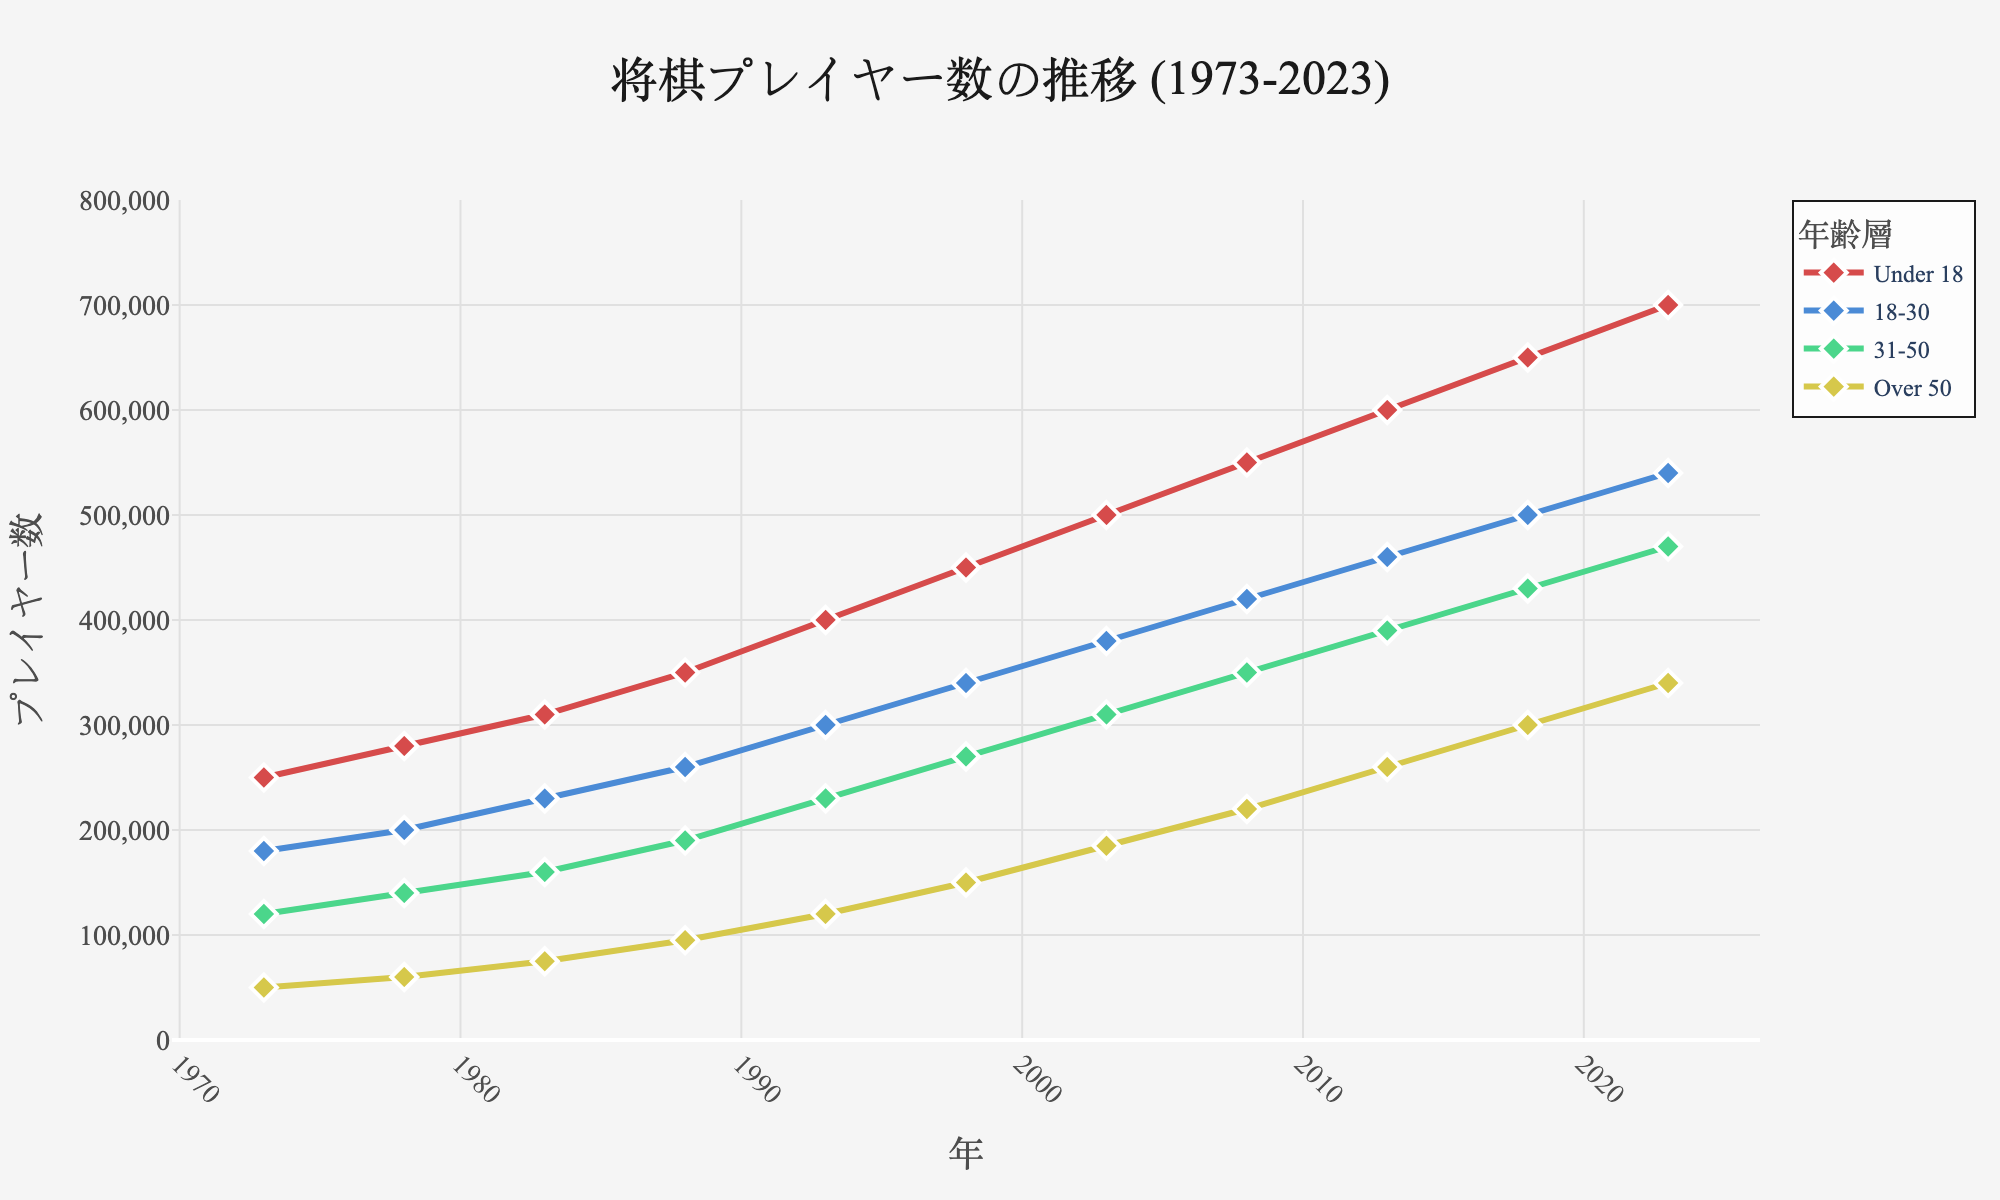What is the trend of shogi players in the "Under 18" age group over the past 50 years? The "Under 18" age group shows a steadily increasing trend in the number of shogi players from 250,000 in 1973 to 700,000 in 2023. This indicates a growing interest among the younger population over time.
Answer: Increasing Compare the number of shogi players in the "18-30" age group with the "31-50" age group in 2023. Which group has more players? In 2023, the number of shogi players in the "18-30" age group is 540,000, while in the "31-50" age group, it is 470,000. By comparing these numbers, the "18-30" age group has more players than the "31-50" age group.
Answer: "18-30" age group Among which age group(s) do you see a marked increase in the number of players post-2003? Post-2003, both the "Under 18" and "Over 50" age groups see a marked increase. The "Under 18" group rises from 500,000 (2003) to 700,000 (2023) and the "Over 50" group moves from 185,000 (2003) to 340,000 (2023), showing a growing trend in these age groups.
Answer: "Under 18" and "Over 50" age groups What is the visual color used for the "31-50" age group line in the graph? The "31-50" age group line in the graph is represented by a green color, which differentiates it from the other age groups.
Answer: Green Calculate the average number of shogi players in the "Over 50" age group for the first and last record years (1973 and 2023). To get the average, sum the number of shogi players in 1973 (50,000) and 2023 (340,000), which equals 390,000. Then, divide by 2: 390,000 / 2 = 195,000.
Answer: 195,000 Which age group shows the highest number of shogi players in the year 2018, and what is the value? In the year 2018, the "Under 18" age group shows the highest number of shogi players at 650,000, more than any other age group in that year.
Answer: "Under 18", 650,000 From 1973 to 2023, by how much did the number of shogi players in the "31-50" age group increase? The number of shogi players in the "31-50" age group increased from 120,000 in 1973 to 470,000 in 2023. The increase can be calculated as 470,000 - 120,000 = 350,000.
Answer: 350,000 